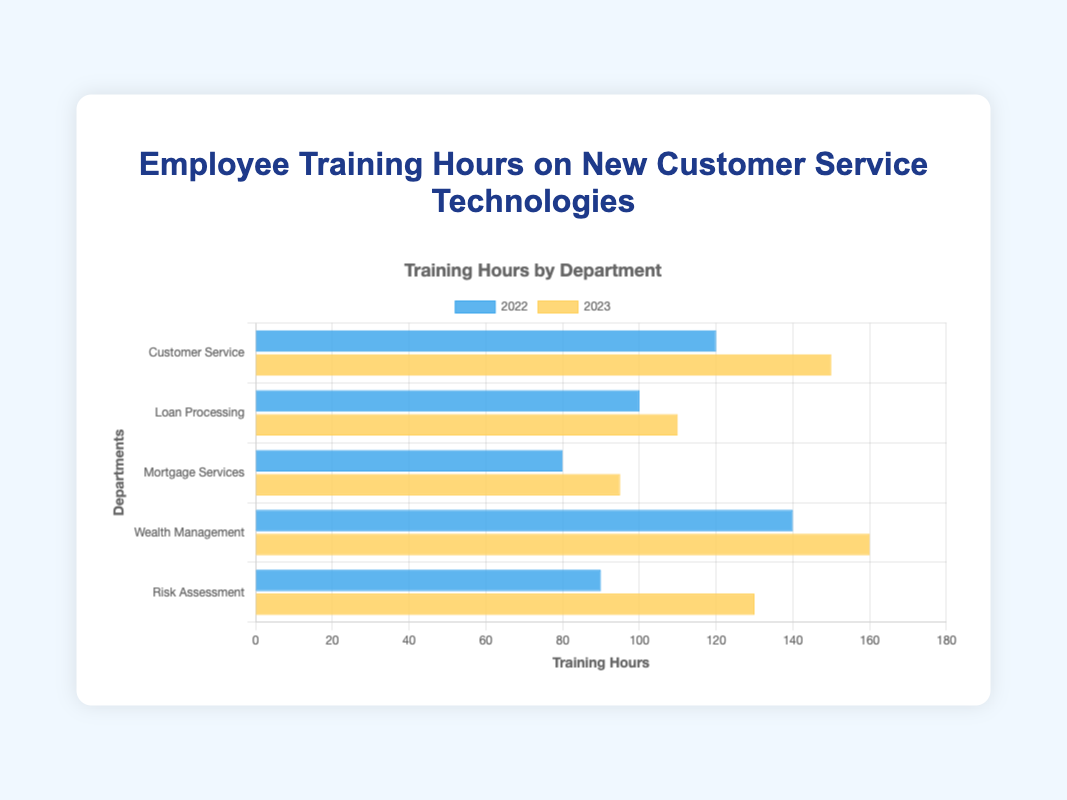Which department had the highest increase in training hours from 2022 to 2023? Subtract the training hours of each department in 2022 from their respective hours in 2023. The increases are: Customer Service (150-120=30), Loan Processing (110-100=10), Mortgage Services (95-80=15), Wealth Management (160-140=20), Risk Assessment (130-90=40). The highest increase is in Risk Assessment with 40 hours.
Answer: Risk Assessment Which department had the least change in training hours between 2022 and 2023? Calculate the difference in training hours for each department between 2022 and 2023: Customer Service (150-120=30), Loan Processing (110-100=10), Mortgage Services (95-80=15), Wealth Management (160-140=20), Risk Assessment (130-90=40). The least change is in Loan Processing with a 10-hour increase.
Answer: Loan Processing By how many hours did training in Wealth Management increase from 2022 to 2023? Subtract the training hours in 2022 from those in 2023 for Wealth Management: 160 - 140 = 20.
Answer: 20 Compare the total training hours for all departments in 2022 versus 2023 and identify which year had more training hours overall. Sum the training hours for all departments in both years: 2022 (120+100+80+140+90=530) and 2023 (150+110+95+160+130=645). Compare the totals: 645 is greater than 530, indicating that 2023 had more training hours overall.
Answer: 2023 had more training hours Which department had the most consistent training hours between 2022 and 2023? Consistency can be measured by the smallest difference in training hours between the two years. Calculate the differences: Customer Service (30), Loan Processing (10), Mortgage Services (15), Wealth Management (20), Risk Assessment (40). The smallest difference is in Loan Processing with a 10-hour difference.
Answer: Loan Processing In 2023, which department had the second highest training hours and what were they? Rank the departments based on their training hours in 2023: Wealth Management (160), Customer Service (150), Risk Assessment (130), Loan Processing (110), Mortgage Services (95). The second highest training hours were in Customer Service with 150 hours.
Answer: Customer Service, 150 How does the total increase in training hours for all departments from 2022 to 2023 compare to their total hours in 2022? First, calculate the total training hours for all departments in each year (2022: 530, 2023: 645). The total increase is 645 - 530 = 115. Now, compare 115 to the total hours in 2022, which is 530. The increase is less than the total training hours in 2022.
Answer: The increase (115) is less than the total hours in 2022 (530) Which department had fewer training hours in 2023 than Wealth Management did in 2022? Wealth Management had 140 training hours in 2022. Compare this to the hours for each department in 2023: Customer Service (150), Loan Processing (110), Mortgage Services (95), Wealth Management (160), Risk Assessment (130). The departments with fewer hours are Loan Processing and Mortgage Services.
Answer: Loan Processing and Mortgage Services What is the average training hours per department in 2023? Sum the total training hours for all departments in 2023 and divide by the number of departments: (150+110+95+160+130)/5 = 645/5 = 129.
Answer: 129 